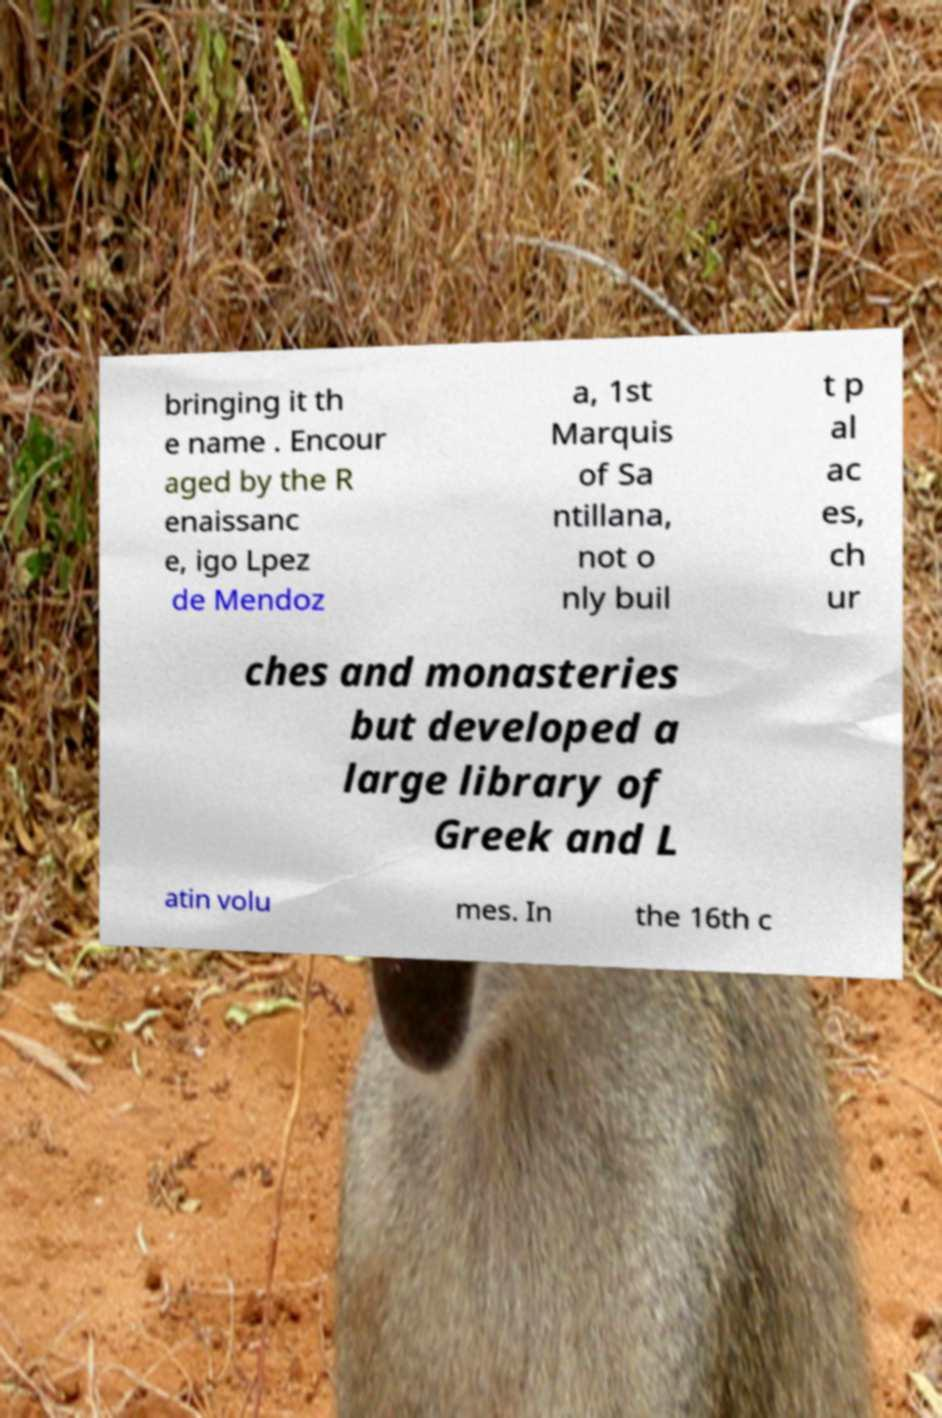Can you read and provide the text displayed in the image?This photo seems to have some interesting text. Can you extract and type it out for me? bringing it th e name . Encour aged by the R enaissanc e, igo Lpez de Mendoz a, 1st Marquis of Sa ntillana, not o nly buil t p al ac es, ch ur ches and monasteries but developed a large library of Greek and L atin volu mes. In the 16th c 